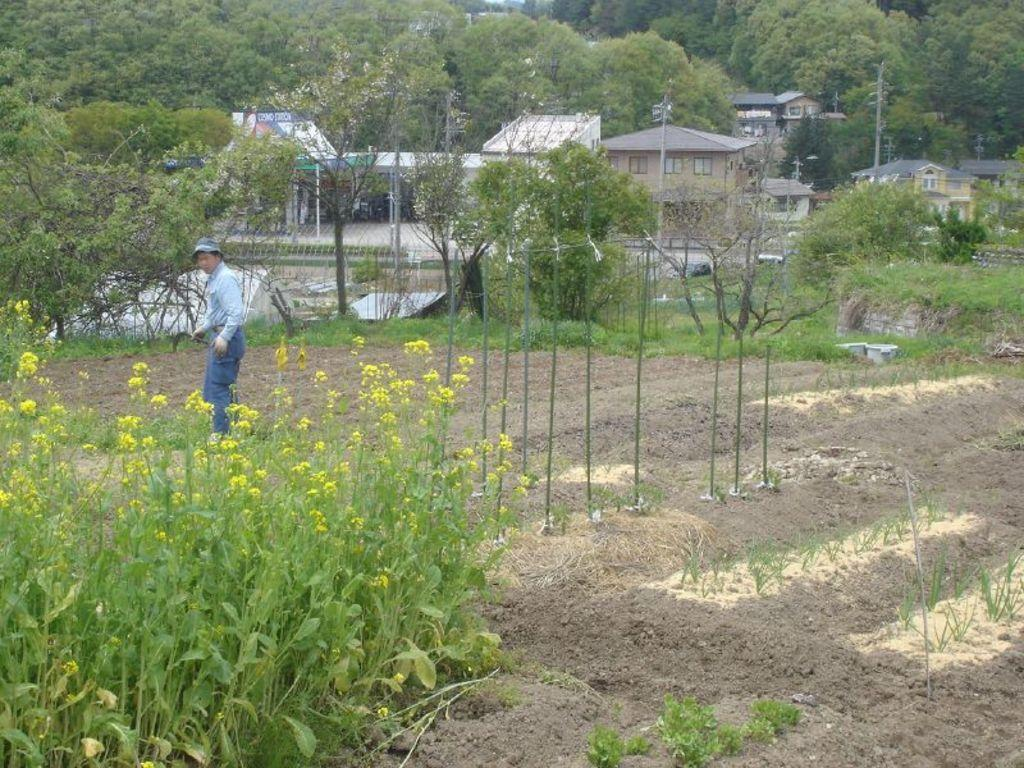What type of living organisms can be seen in the image? Plants and trees are visible in the image. What structures can be seen in the image? Poles and houses are visible in the image. What natural feature is present in the image? A lake is visible in the image. Can you describe the person in the image? There is a person in the image, but no specific details about their appearance or actions are provided. How many giraffes are visible in the image? There are no giraffes present in the image. What type of steel structure can be seen in the image? There is no steel structure present in the image. 